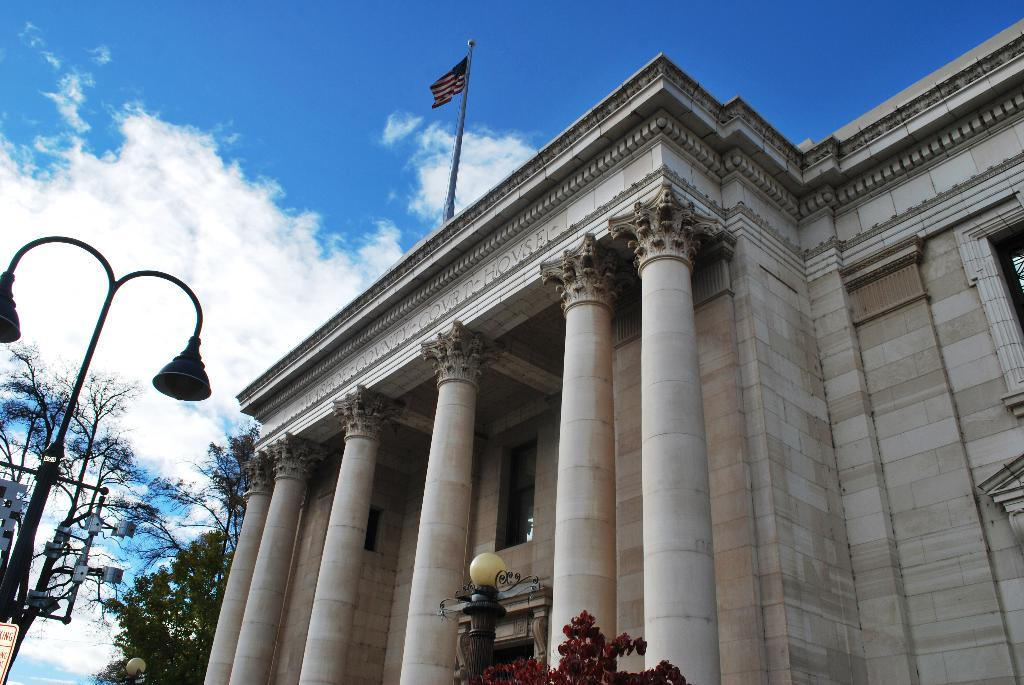What type of structure is depicted in the image? There is a building with pillars in the image. What can be seen in front of the building? There are lights in front of the building. What type of vegetation is located beside the building? There are trees beside the building. What is visible in the background of the image? The sky is visible in the background of the image. What type of plant is the daughter watering in the image? There is no daughter or plant present in the image. What type of beef is being served at the event in the image? There is no event or beef present in the image. 